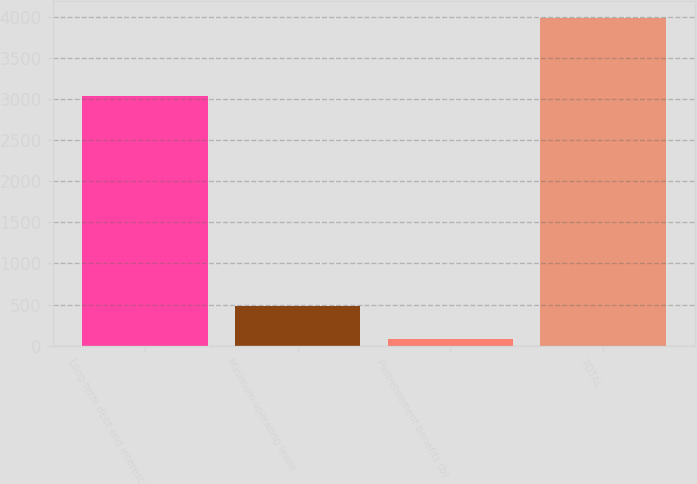<chart> <loc_0><loc_0><loc_500><loc_500><bar_chart><fcel>Long-term debt and interest<fcel>Minimum operating lease<fcel>Postretirement benefits (b)<fcel>TOTAL<nl><fcel>3041<fcel>476.83<fcel>86.9<fcel>3986.2<nl></chart> 